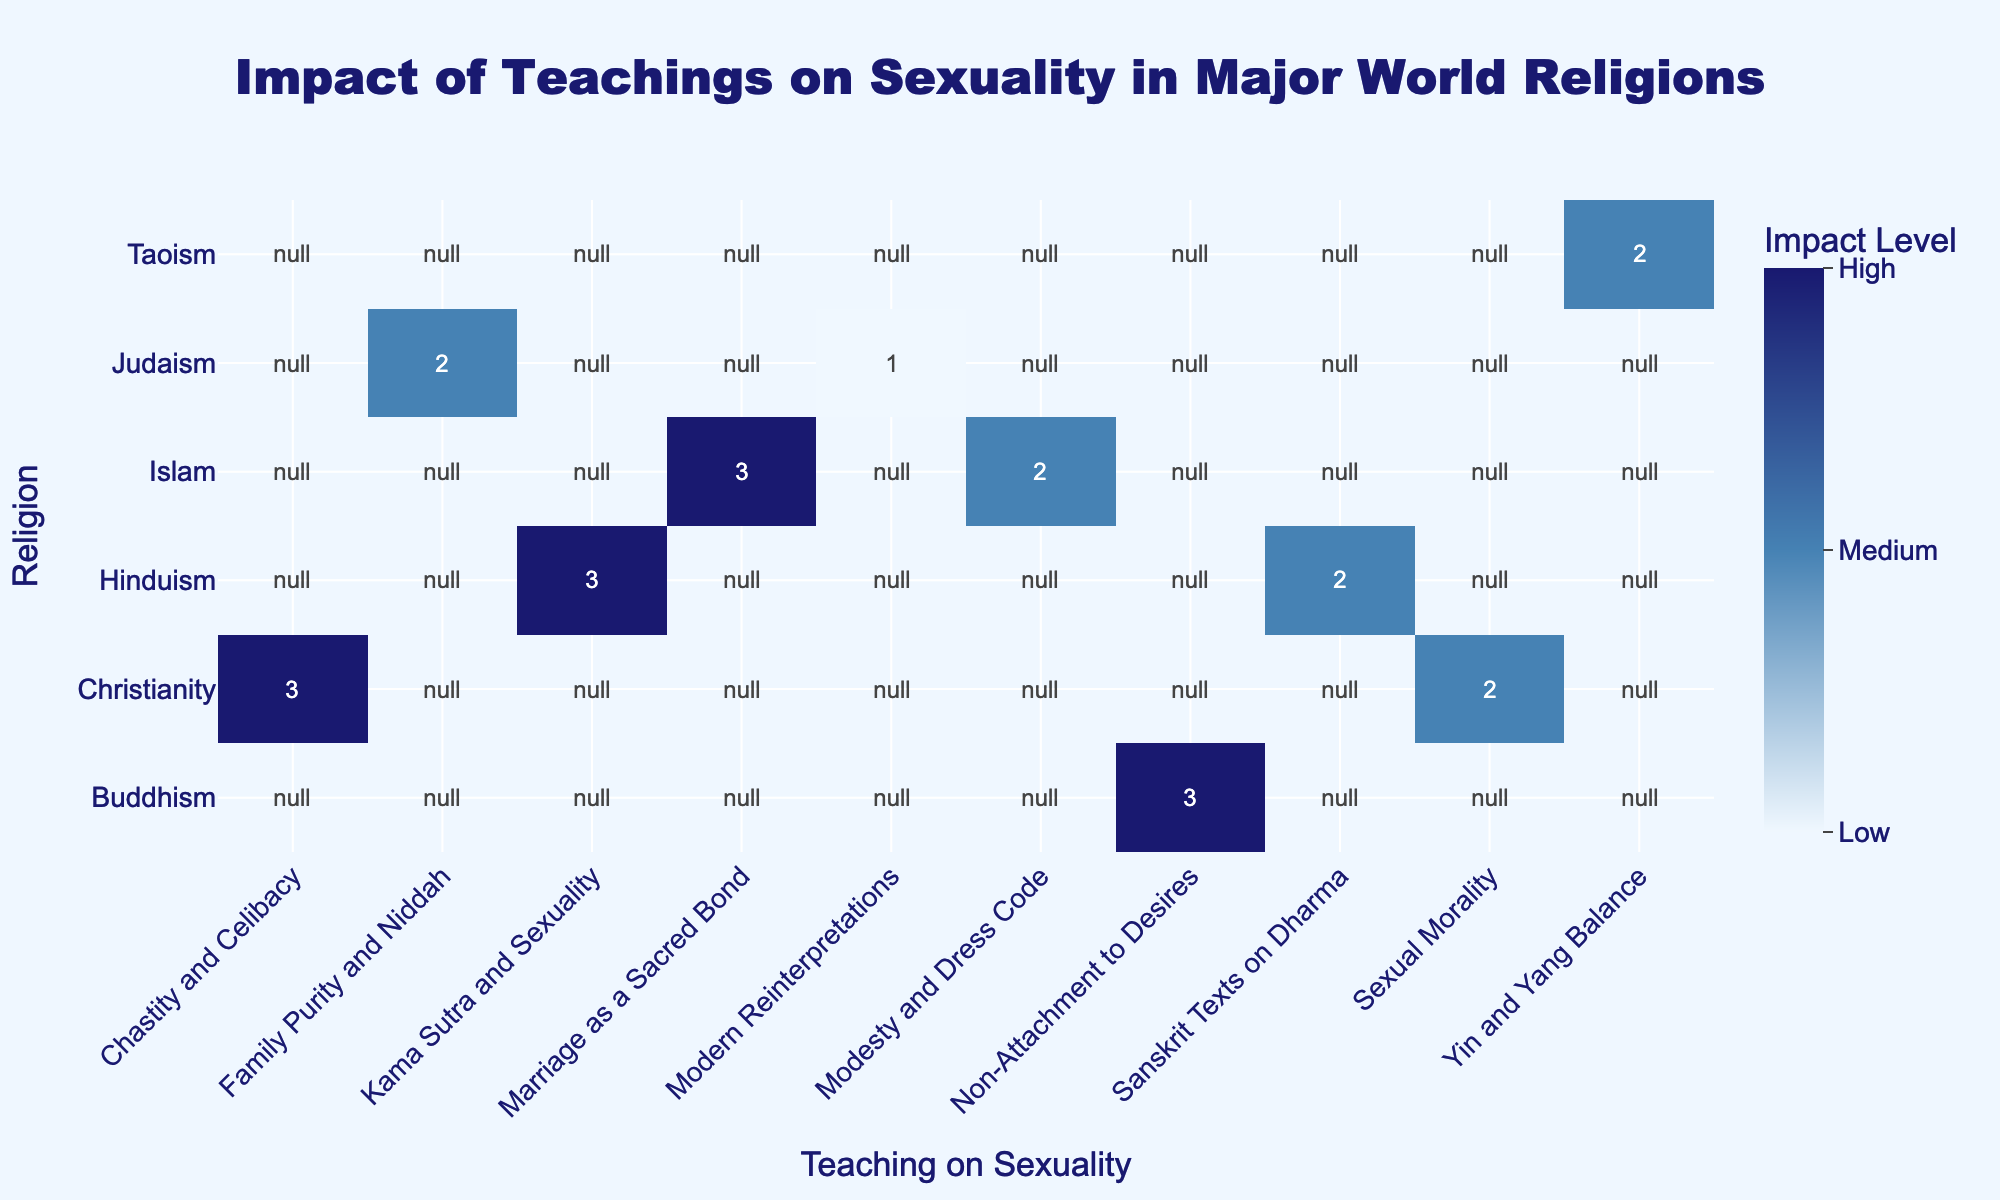What is the impact level of "Chastity and Celibacy" in Christianity? According to the table, "Chastity and Celibacy" in Christianity has a recorded impact level of High, corresponding to a value of 3.
Answer: High How many teachings on sexuality had a Medium impact level? In the table, "Sexual Morality," "Modesty and Dress Code," "Sanskrit Texts on Dharma," "Family Purity and Niddah," and "Yin and Yang Balance" are listed, making a total of 5 teachings with a Medium impact level.
Answer: 5 Does Judaism have any teaching on sexuality with a High impact level? Yes, the teaching "Family Purity and Niddah" under Judaism has a High impact level, as indicated by the corresponding value of 3 in the table.
Answer: Yes Which religion has the most teachings listed on sexuality with a High impact level? Christianity has only one teaching listed as High impact; Islam has one; Hinduism has one; Buddhism has one. Therefore, they are all equal in this aspect, with each having one High impact teaching.
Answer: Equal among several religions What is the average impact level of all teachings on sexuality listed in the table? By listing the impact levels numerically (High = 3, Medium = 2, Low = 1), we have: (3 + 2 + 3 + 2 + 3 + 3 + 2 + 1) = 19 with 8 total teachings, so the average is 19/8 = 2.375 which corresponds to a value closer to Medium.
Answer: 2.375, approximately Medium What is the historical period for the teaching "Kama Sutra and Sexuality"? The table clearly states that "Kama Sutra and Sexuality" is from the 2nd Century CE.
Answer: 2nd Century CE Is there a teaching on sexuality from Buddhism with a Low impact level? No, all teachings on sexuality listed under Buddhism, namely "Non-Attachment to Desires," have a recorded impact level of High.
Answer: No What is the teaching with the highest impact level during the 1st Century CE? The highest impact level teaching during the 1st Century CE is "Chastity and Celibacy" in Christianity, which is categorized as High.
Answer: Chastity and Celibacy 